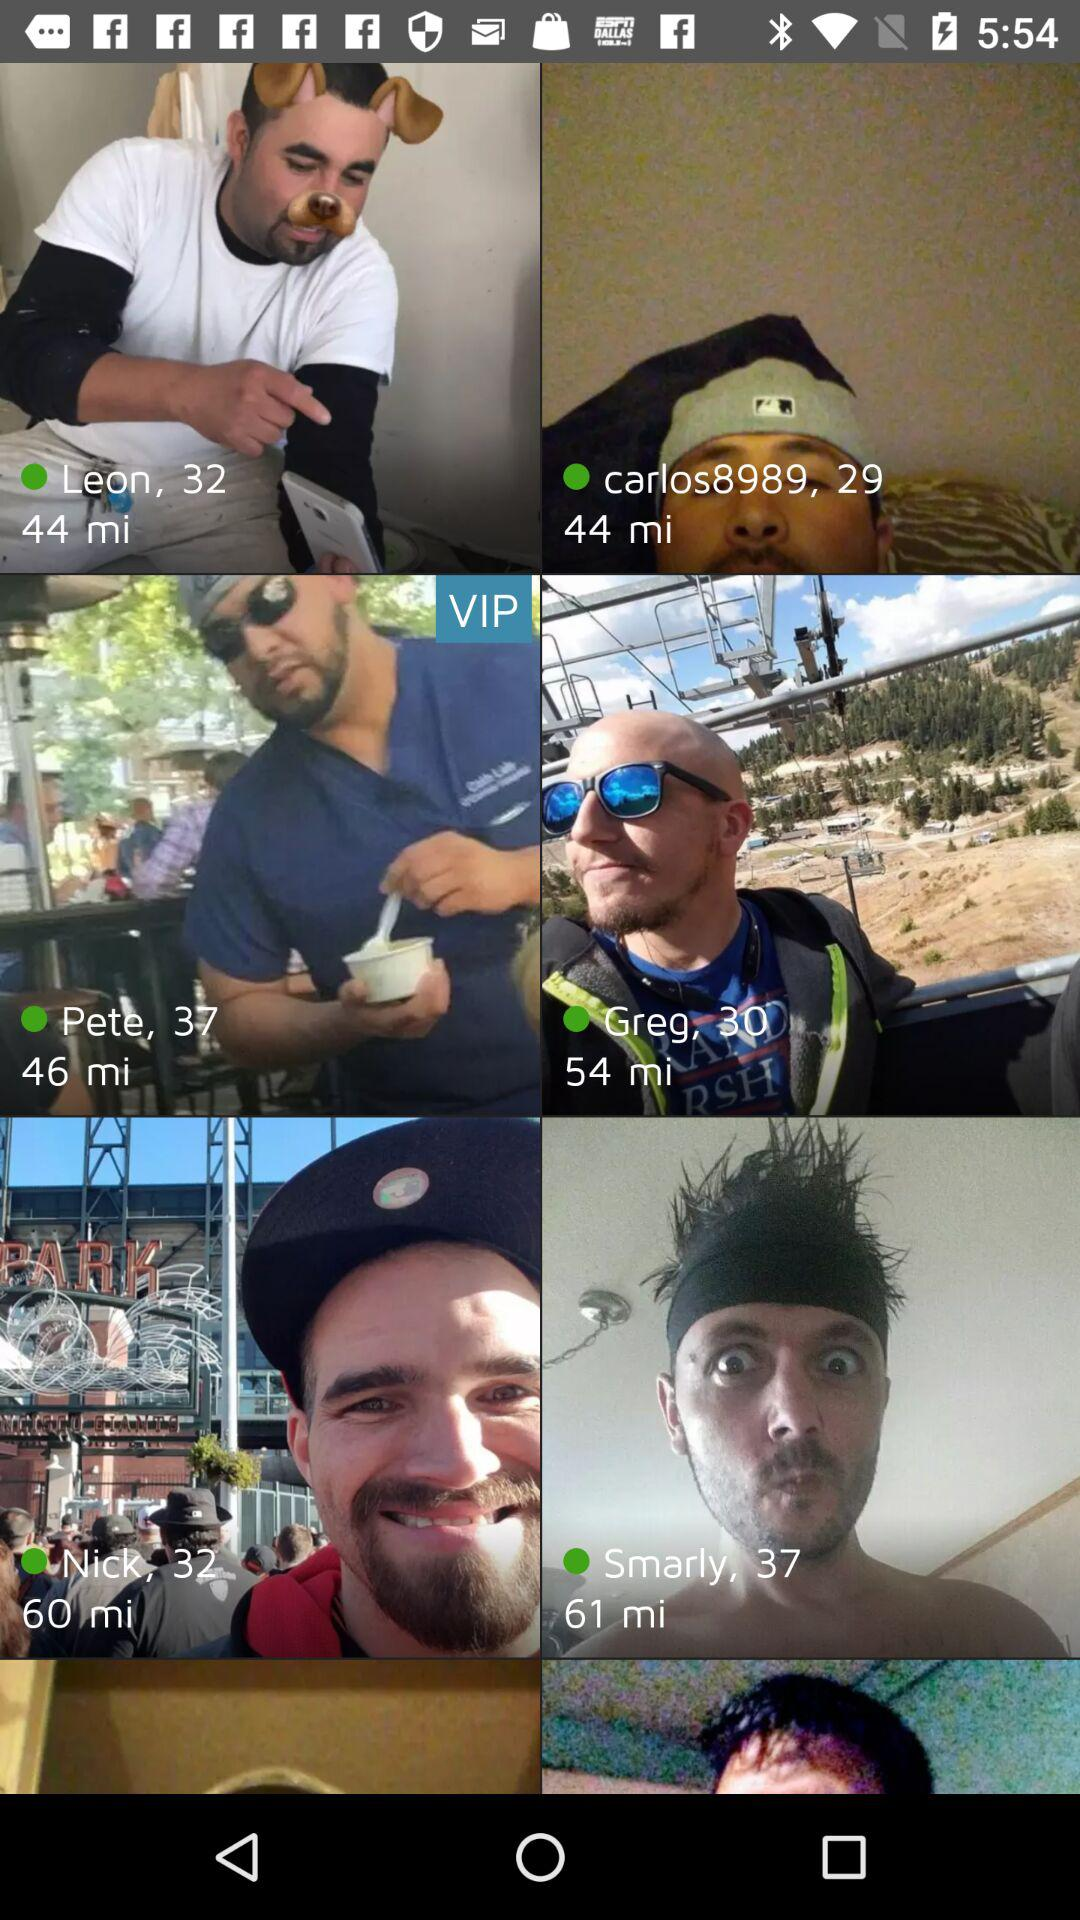60 minutes ago, which user uploaded the image?
When the provided information is insufficient, respond with <no answer>. <no answer> 